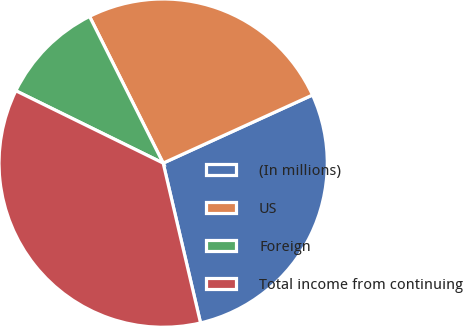<chart> <loc_0><loc_0><loc_500><loc_500><pie_chart><fcel>(In millions)<fcel>US<fcel>Foreign<fcel>Total income from continuing<nl><fcel>28.15%<fcel>25.59%<fcel>10.33%<fcel>35.92%<nl></chart> 